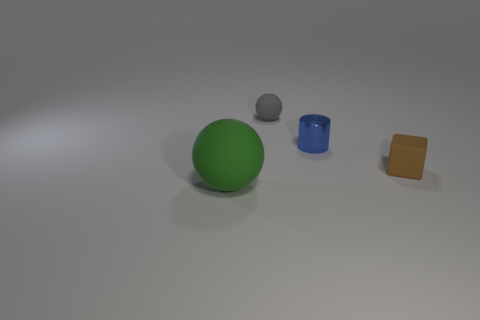Add 4 big blue blocks. How many objects exist? 8 Subtract all cubes. How many objects are left? 3 Subtract all big green rubber things. Subtract all small metallic objects. How many objects are left? 2 Add 1 gray matte objects. How many gray matte objects are left? 2 Add 2 gray matte spheres. How many gray matte spheres exist? 3 Subtract 0 cyan cylinders. How many objects are left? 4 